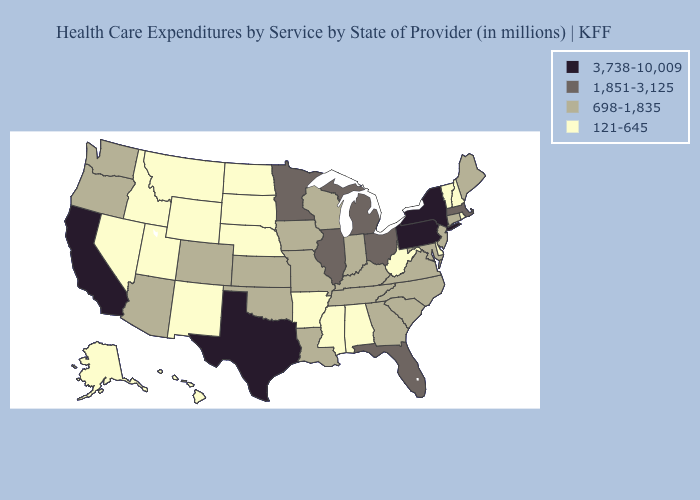What is the lowest value in the USA?
Be succinct. 121-645. Among the states that border Mississippi , does Tennessee have the highest value?
Keep it brief. Yes. What is the highest value in the USA?
Quick response, please. 3,738-10,009. Name the states that have a value in the range 698-1,835?
Concise answer only. Arizona, Colorado, Connecticut, Georgia, Indiana, Iowa, Kansas, Kentucky, Louisiana, Maine, Maryland, Missouri, New Jersey, North Carolina, Oklahoma, Oregon, South Carolina, Tennessee, Virginia, Washington, Wisconsin. Among the states that border Vermont , which have the highest value?
Answer briefly. New York. Does California have the highest value in the USA?
Quick response, please. Yes. Which states hav the highest value in the Northeast?
Quick response, please. New York, Pennsylvania. Name the states that have a value in the range 3,738-10,009?
Keep it brief. California, New York, Pennsylvania, Texas. What is the lowest value in states that border Montana?
Keep it brief. 121-645. Name the states that have a value in the range 121-645?
Write a very short answer. Alabama, Alaska, Arkansas, Delaware, Hawaii, Idaho, Mississippi, Montana, Nebraska, Nevada, New Hampshire, New Mexico, North Dakota, Rhode Island, South Dakota, Utah, Vermont, West Virginia, Wyoming. What is the highest value in states that border Rhode Island?
Be succinct. 1,851-3,125. What is the value of Wisconsin?
Give a very brief answer. 698-1,835. Does Idaho have a higher value than New Mexico?
Short answer required. No. What is the value of Alaska?
Write a very short answer. 121-645. What is the highest value in the USA?
Be succinct. 3,738-10,009. 